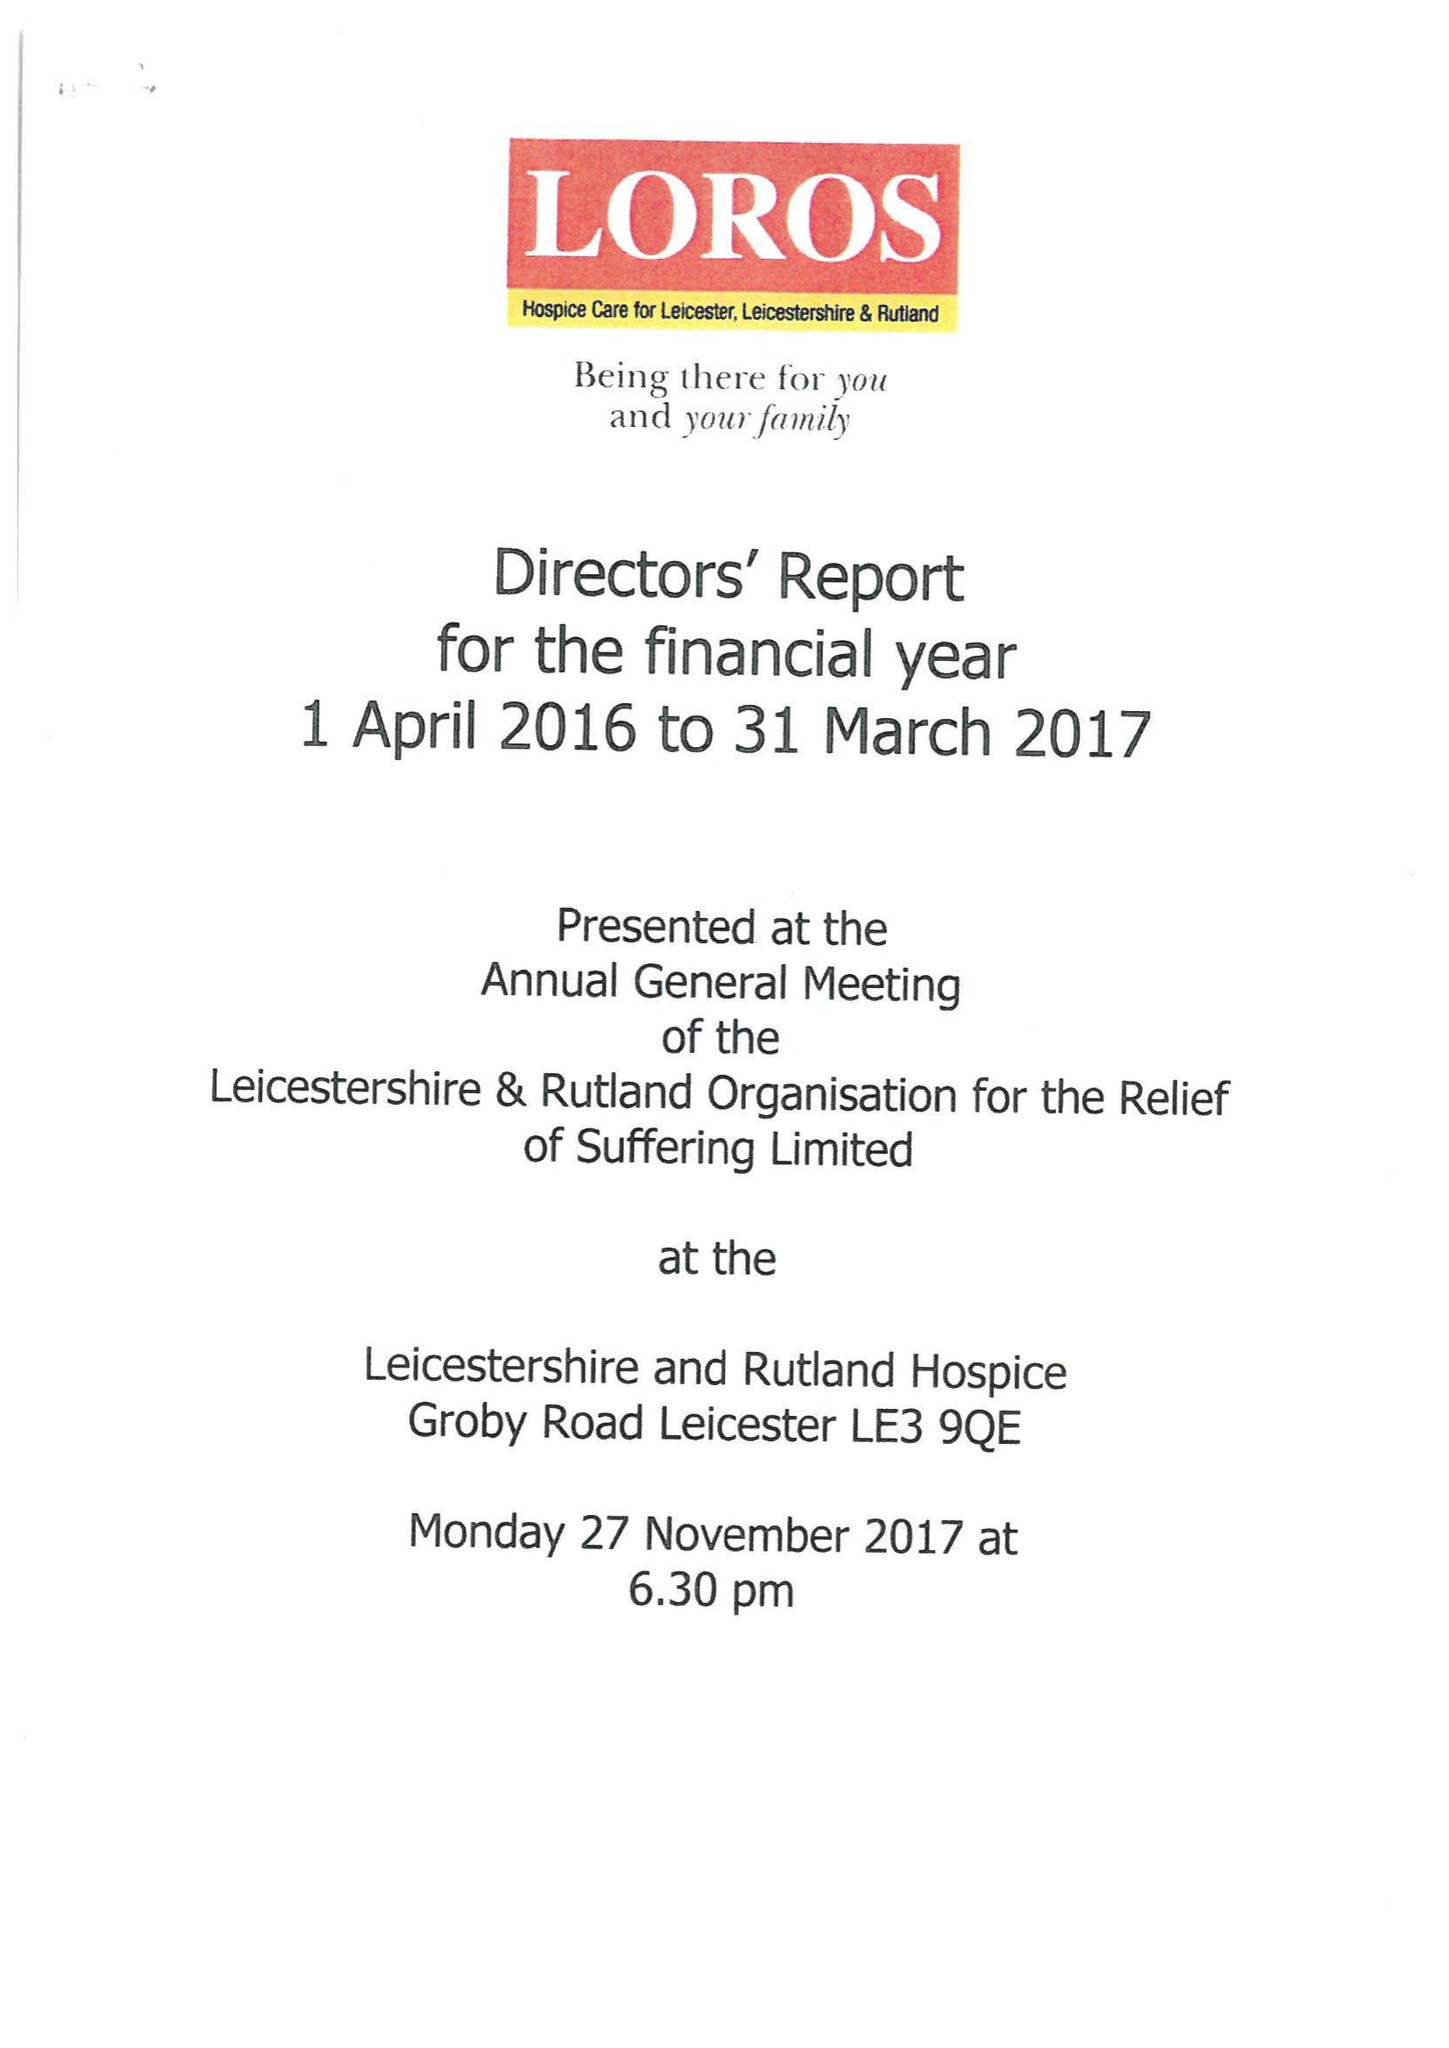What is the value for the charity_number?
Answer the question using a single word or phrase. 506120 